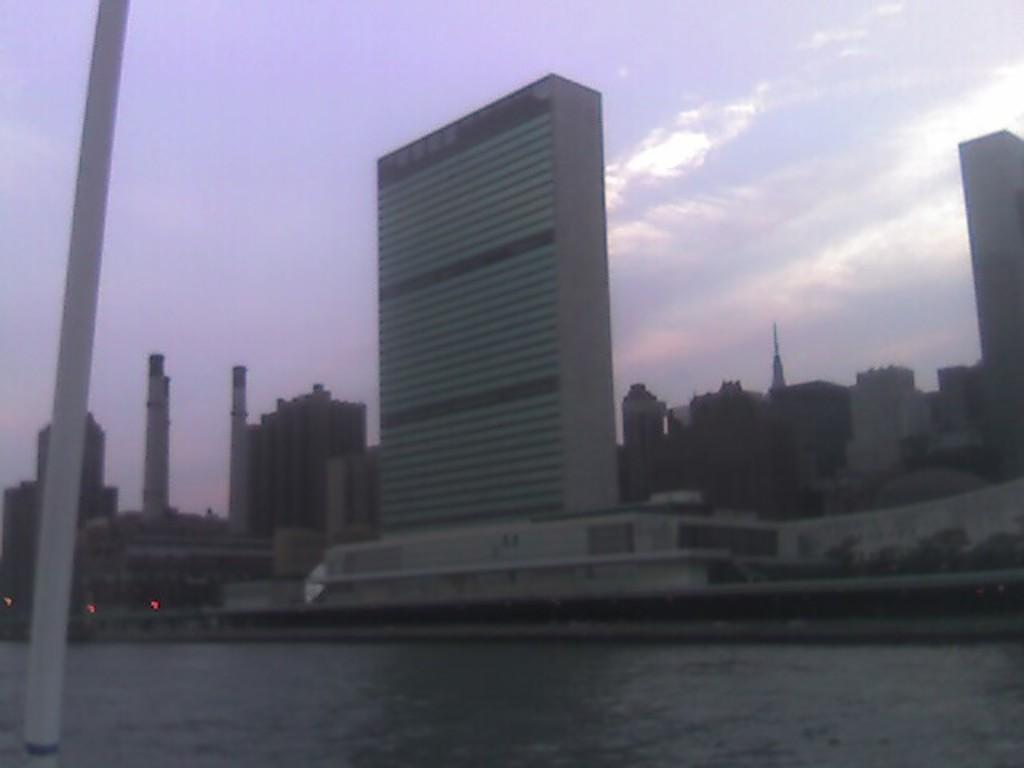What is visible in the image? Water is visible in the image. Can you describe any structures in the image? There is a white-colored pole in the image. What can be seen in the background of the image? There are buildings, trees, lights, and the sky visible in the background of the image. What type of dress is being worn by the beef in the image? There is no dress or beef present in the image. What sound can be heard coming from the lights in the image? The image does not contain any sounds, so it is not possible to determine what sound might be coming from the lights. 